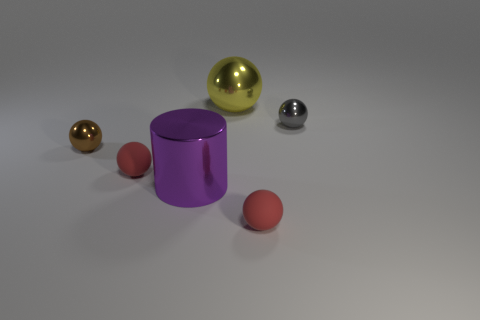What number of balls are small red things or tiny brown metallic objects?
Make the answer very short. 3. There is a small object that is both on the left side of the yellow thing and on the right side of the small brown metal ball; what is its shape?
Your response must be concise. Sphere. Is the number of big cylinders that are left of the brown ball the same as the number of balls that are to the right of the purple metallic object?
Provide a succinct answer. No. What number of objects are either tiny gray metal things or rubber things?
Your answer should be very brief. 3. There is another thing that is the same size as the yellow object; what is its color?
Provide a short and direct response. Purple. What number of objects are either small spheres that are in front of the purple object or red matte objects that are behind the purple cylinder?
Your answer should be very brief. 2. Are there the same number of purple metal cylinders behind the gray ball and tiny brown shiny objects?
Keep it short and to the point. No. Is the size of the metal sphere in front of the tiny gray thing the same as the sphere behind the gray metallic sphere?
Offer a very short reply. No. How many other objects are there of the same size as the purple thing?
Your response must be concise. 1. There is a tiny red ball that is on the left side of the large shiny object that is in front of the tiny brown metallic thing; is there a red matte sphere left of it?
Offer a terse response. No. 